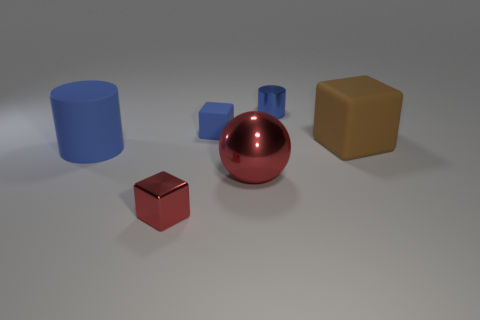Is the large cylinder the same color as the small cylinder?
Your answer should be very brief. Yes. Is there a big blue rubber cylinder that is behind the large matte thing that is right of the small metal thing in front of the brown block?
Provide a succinct answer. No. How many other blue metal cylinders are the same size as the blue shiny cylinder?
Ensure brevity in your answer.  0. There is a blue cylinder that is to the right of the tiny red metal thing; does it have the same size as the blue cylinder that is to the left of the large shiny thing?
Ensure brevity in your answer.  No. The object that is to the right of the red block and in front of the brown matte cube has what shape?
Provide a succinct answer. Sphere. Is there a matte cube of the same color as the tiny metallic cylinder?
Give a very brief answer. Yes. Are any large green cylinders visible?
Your answer should be compact. No. What color is the cylinder right of the blue matte cylinder?
Provide a short and direct response. Blue. Does the blue matte block have the same size as the red block left of the small blue metallic cylinder?
Provide a short and direct response. Yes. What is the size of the object that is left of the blue cube and to the right of the big cylinder?
Your answer should be compact. Small. 